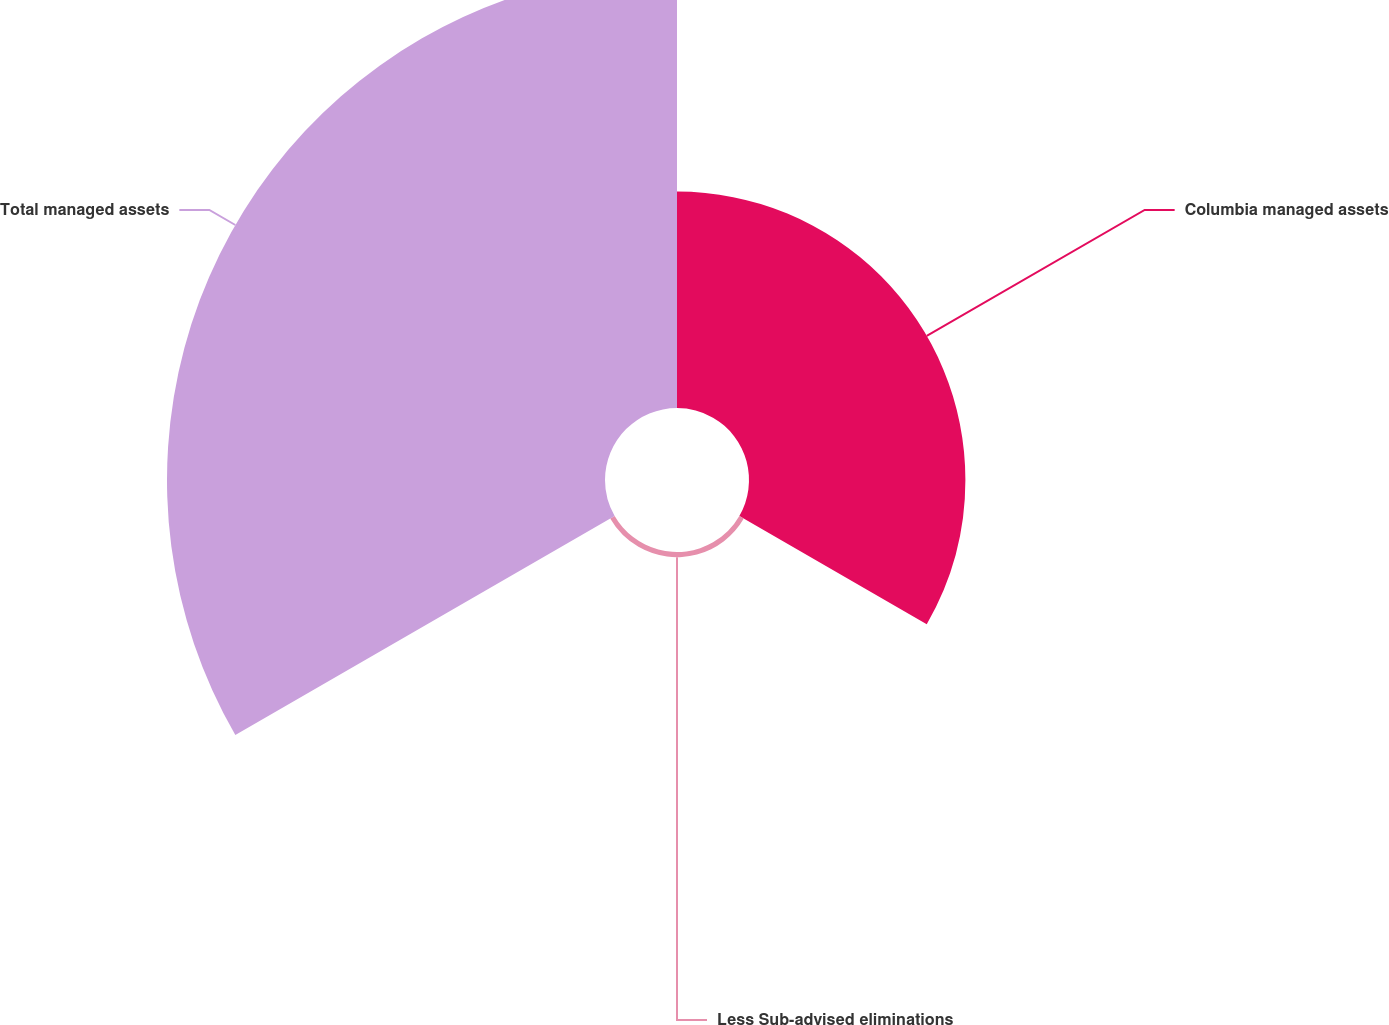Convert chart to OTSL. <chart><loc_0><loc_0><loc_500><loc_500><pie_chart><fcel>Columbia managed assets<fcel>Less Sub-advised eliminations<fcel>Total managed assets<nl><fcel>32.81%<fcel>0.78%<fcel>66.41%<nl></chart> 